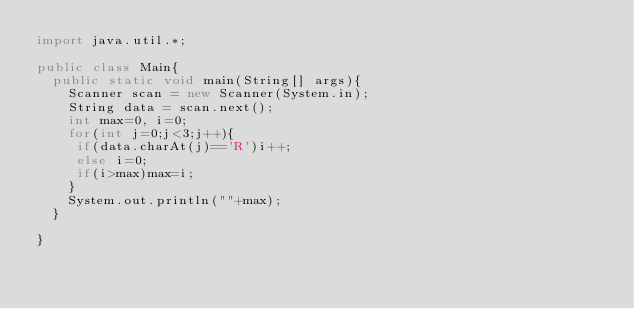<code> <loc_0><loc_0><loc_500><loc_500><_Java_>import java.util.*;

public class Main{
  public static void main(String[] args){
    Scanner scan = new Scanner(System.in);
    String data = scan.next();
    int max=0, i=0;
    for(int j=0;j<3;j++){
     if(data.charAt(j)=='R')i++;
     else i=0;
     if(i>max)max=i;
    }
    System.out.println(""+max);
  }
  
}</code> 